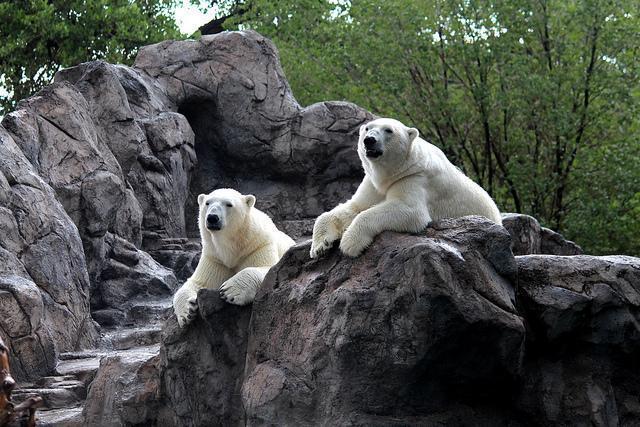How many bears are there?
Give a very brief answer. 2. How many of the tracks have a train on them?
Give a very brief answer. 0. 